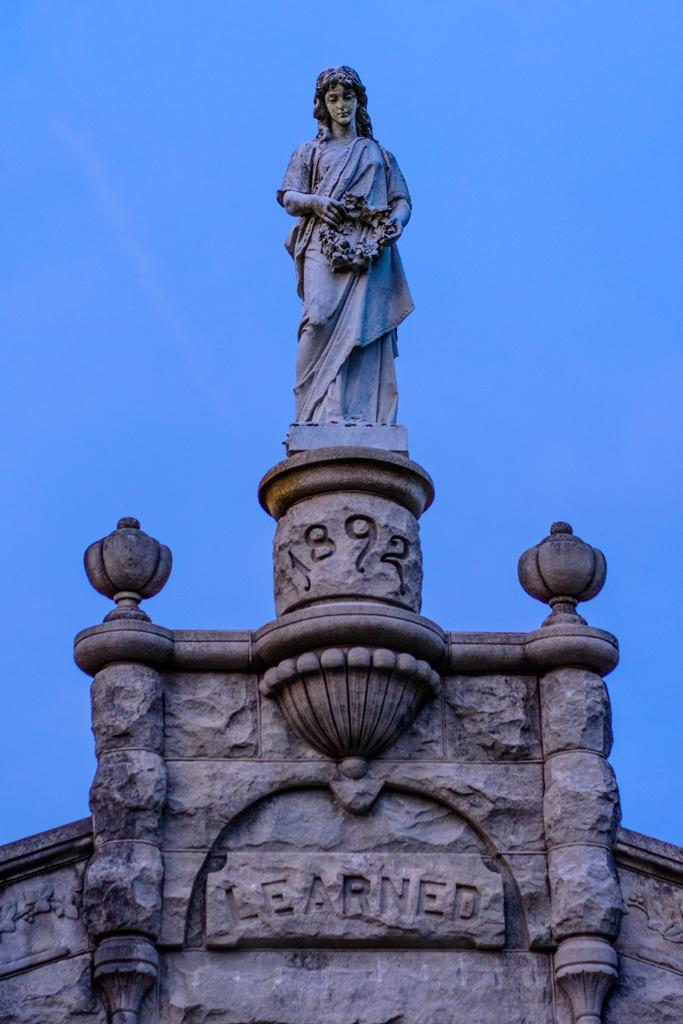What is the main subject of the image? There is a statue in the image. Where is the statue located? The statue is standing on a building. What is the color of the building? The building is white. What can be seen in the background of the image? The sky is blue in the background of the image. How many legs does the statue have in the image? The provided facts do not mention the number of legs the statue has, so it cannot be determined from the image. 